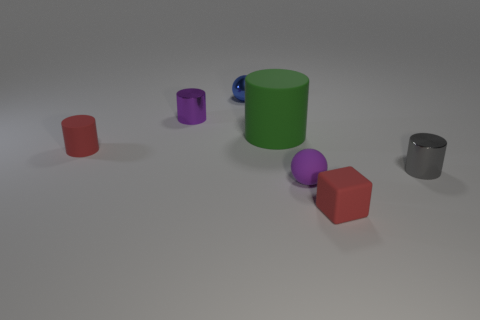Can you describe the lighting and shadows in the image? The image has a soft overhead lighting, casting gentle shadows to the right of the objects, indicating the light source is coming from the upper left. 